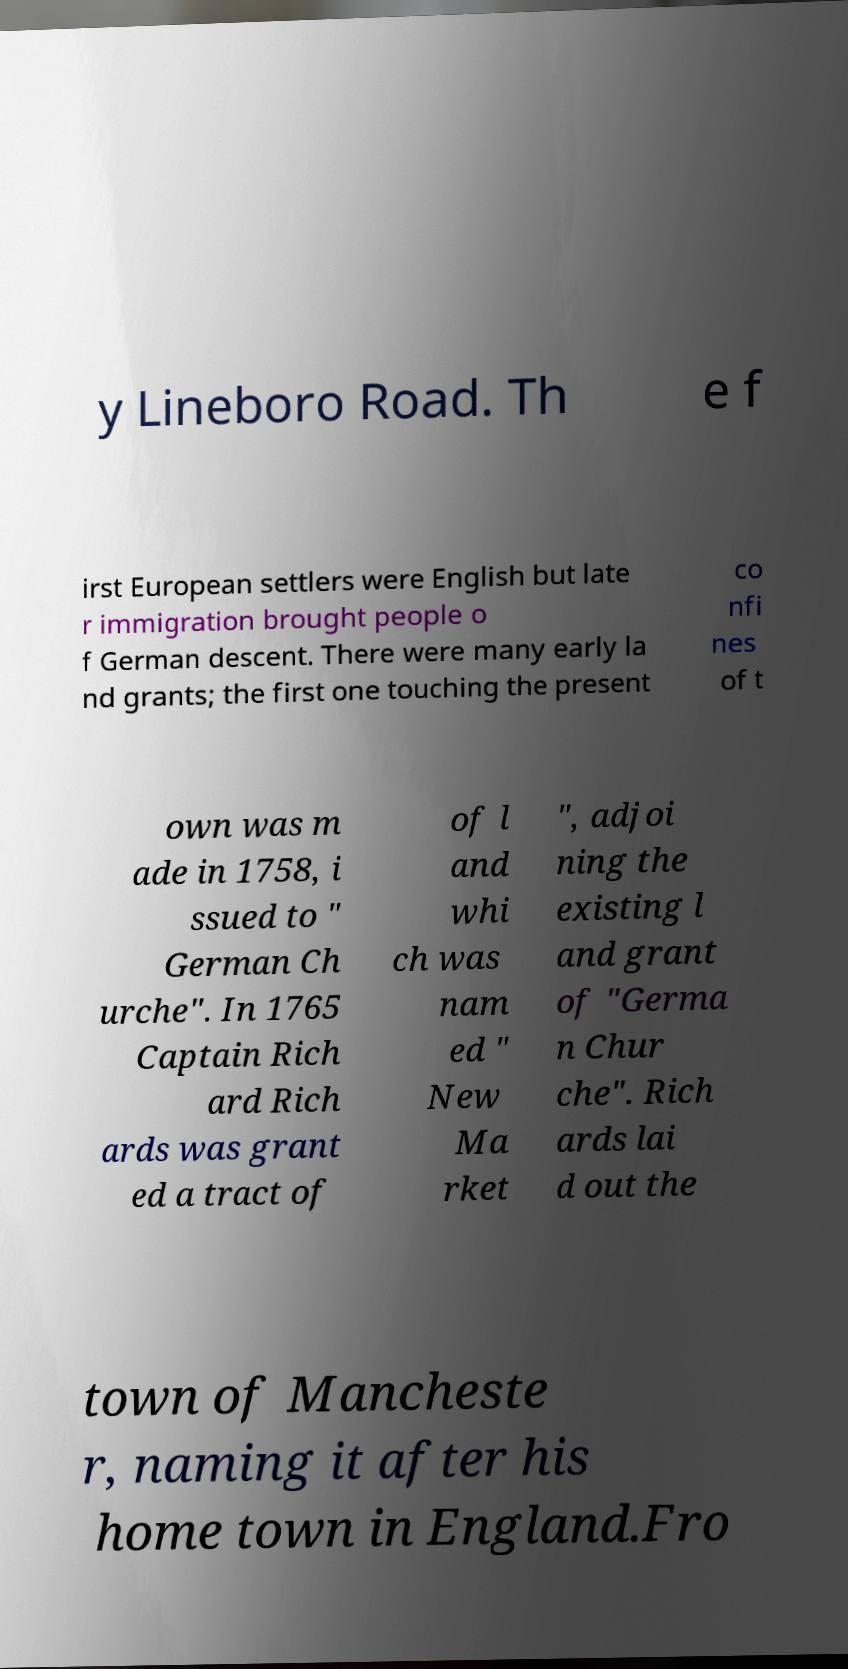Please read and relay the text visible in this image. What does it say? y Lineboro Road. Th e f irst European settlers were English but late r immigration brought people o f German descent. There were many early la nd grants; the first one touching the present co nfi nes of t own was m ade in 1758, i ssued to " German Ch urche". In 1765 Captain Rich ard Rich ards was grant ed a tract of of l and whi ch was nam ed " New Ma rket ", adjoi ning the existing l and grant of "Germa n Chur che". Rich ards lai d out the town of Mancheste r, naming it after his home town in England.Fro 